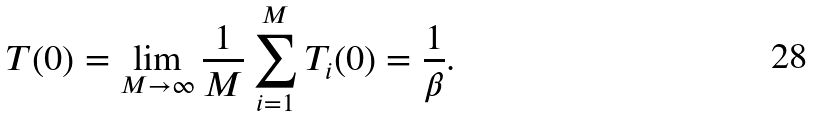<formula> <loc_0><loc_0><loc_500><loc_500>T ( 0 ) = \lim _ { M \rightarrow \infty } \frac { 1 } { M } \sum _ { i = 1 } ^ { M } T _ { i } ( 0 ) = \frac { 1 } { \beta } .</formula> 